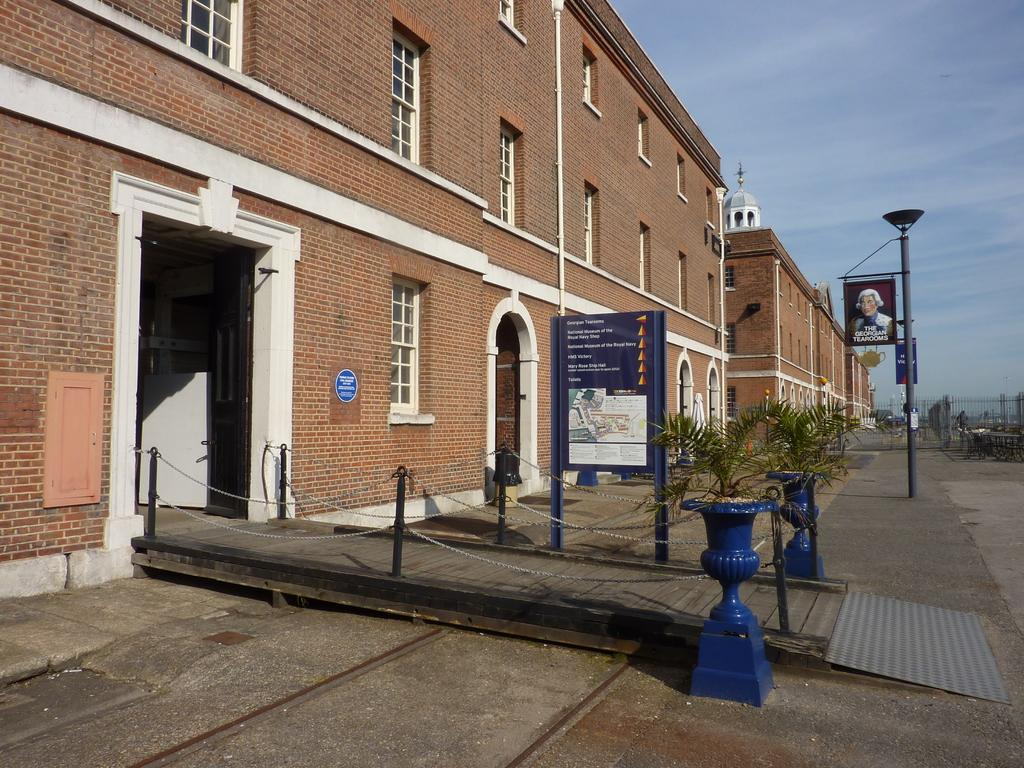What type of structures are present in the image? There are buildings with windows in the image. What can be seen near the buildings? There is a path with plants and poles near the buildings. What is visible in the background of the image? The sky is visible in the background of the image. How do the pigs feel about the buildings in the image? There are no pigs present in the image, so it is not possible to determine their feelings about the buildings. 